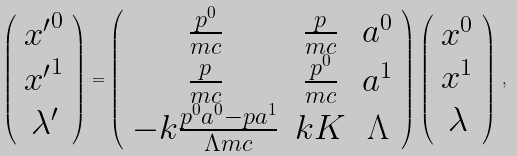Convert formula to latex. <formula><loc_0><loc_0><loc_500><loc_500>\left ( \begin{array} { c } { x ^ { \prime } } ^ { 0 } \\ { x ^ { \prime } } ^ { 1 } \\ \lambda ^ { \prime } \end{array} \right ) = \left ( \begin{array} { c c c } \frac { p ^ { 0 } } { m c } & \frac { p } { m c } & a ^ { 0 } \\ \frac { p } { m c } & \frac { p ^ { 0 } } { m c } & a ^ { 1 } \\ - k \frac { p ^ { 0 } a ^ { 0 } - p a ^ { 1 } } { \Lambda m c } & k K & \Lambda \end{array} \right ) \left ( \begin{array} { c } x ^ { 0 } \\ x ^ { 1 } \\ \lambda \end{array} \right ) \, ,</formula> 